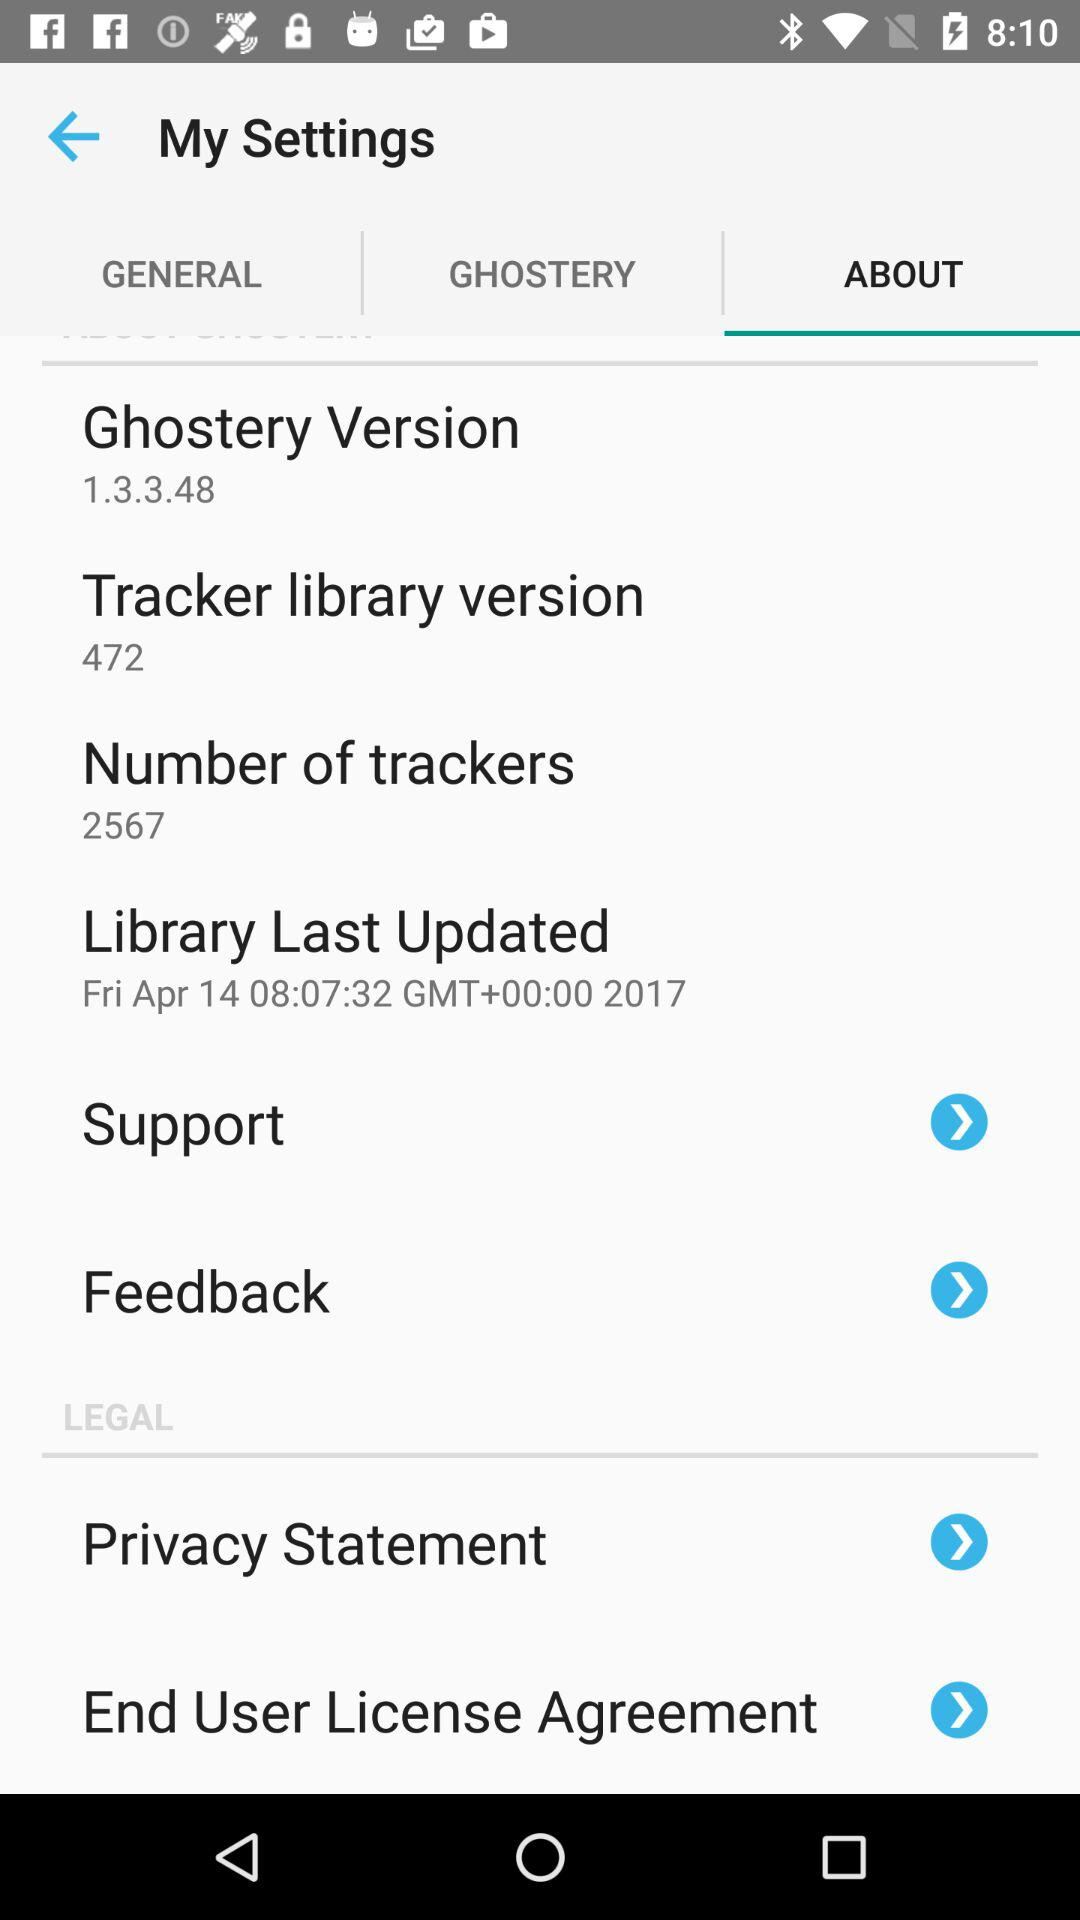What is the number of trackers? The number of trackers is 2567. 